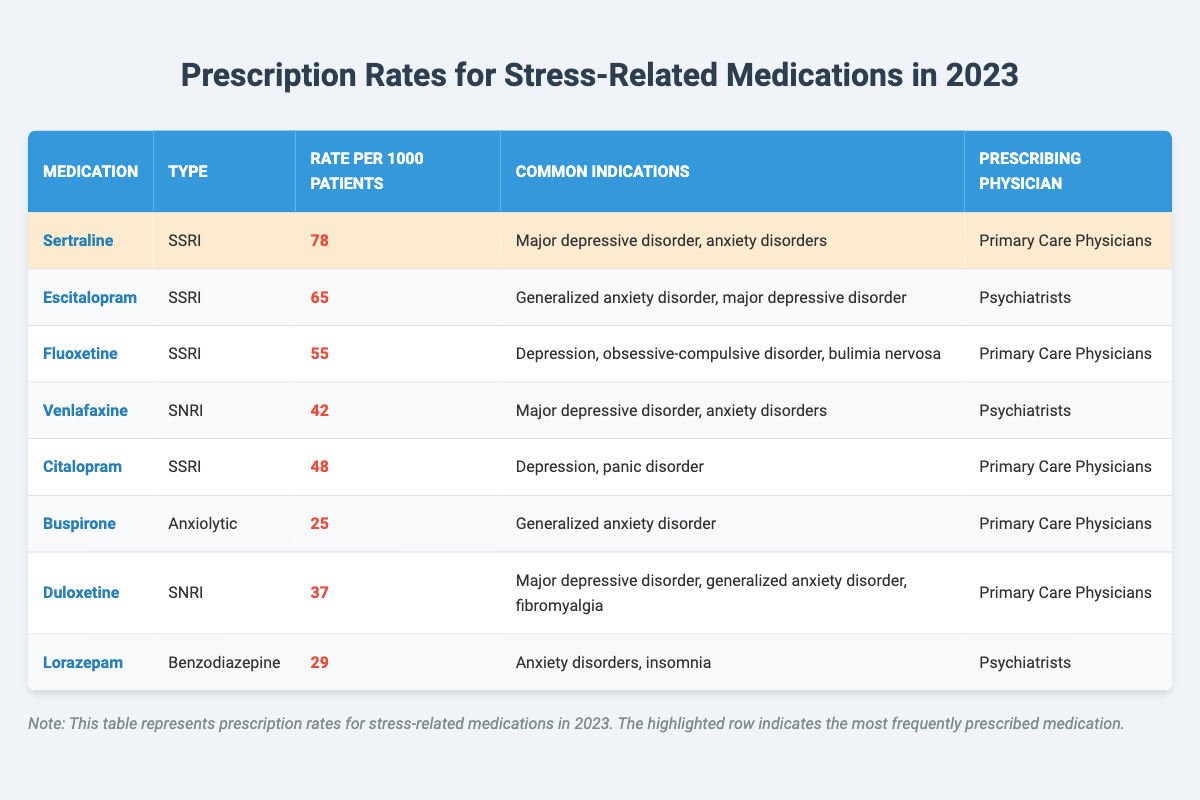What is the highest prescription rate for stress-related medications in 2023? The table lists the prescription rates per 1000 patients for different medications, with Sertraline shown to have the highest rate of 78.
Answer: 78 How many medications are prescribed by primary care physicians? By counting the medications in the table, there are 5 that are prescribed by primary care physicians: Sertraline, Fluoxetine, Citalopram, Buspirone, and Duloxetine.
Answer: 5 What is the prescription rate for Escitalopram? The table indicates that the prescription rate for Escitalopram is 65 per 1000 patients.
Answer: 65 Is the prescription rate for Duloxetine higher than that for Venlafaxine? Comparing the rates in the table, Duloxetine has a prescription rate of 37 and Venlafaxine has a rate of 42. Thus, Duloxetine's rate is lower than Venlafaxine's.
Answer: No What is the average prescription rate for medications prescribed by psychiatrists? The medication rates for psychiatrists are 65 (Escitalopram), 42 (Venlafaxine), and 29 (Lorazepam). The sum is 136, divided by 3 gives an average of approximately 45.33.
Answer: 45.33 Which medication has a prescription rate closest to 30? The table shows that Lorazepam has a prescription rate of 29, which is the closest value to 30 compared to other medications.
Answer: 29 How do the prescription rates for SSRIs compare to those for SNRIs? SSRIs listed are Sertraline (78), Escitalopram (65), Fluoxetine (55), Citalopram (48), and they sum to 346. The SNRIs are Venlafaxine (42) and Duloxetine (37), summing to 79. SSRIs have higher total rates than SNRIs.
Answer: SSRIs have higher rates What is the difference in prescription rates between the medication with the highest and lowest rates? The highest rate is 78 for Sertraline and the lowest rate is 25 for Buspirone. The difference is 78 - 25 = 53.
Answer: 53 Which two medications share common indications for anxiety disorders? The medications Sertraline and Venlafaxine both list anxiety disorders among their common indications.
Answer: Sertraline and Venlafaxine 